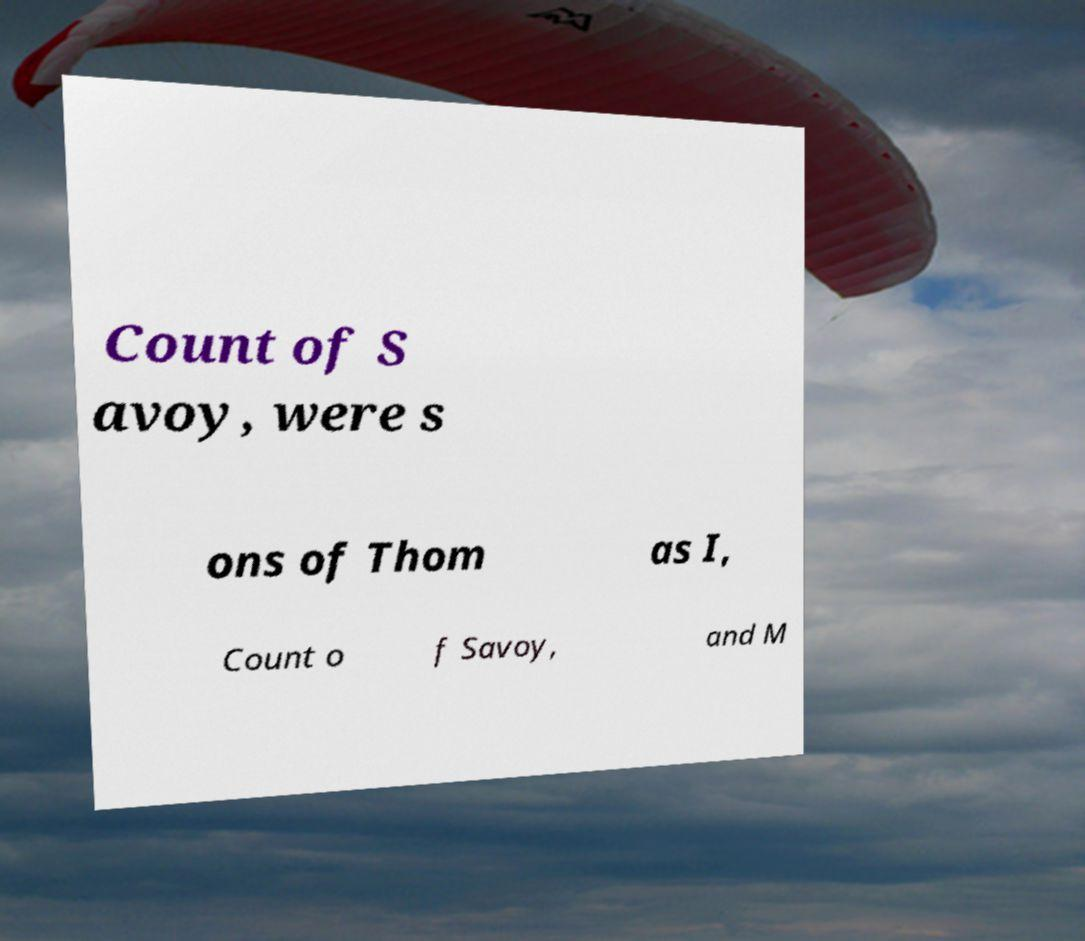There's text embedded in this image that I need extracted. Can you transcribe it verbatim? Count of S avoy, were s ons of Thom as I, Count o f Savoy, and M 